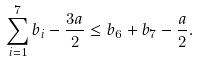Convert formula to latex. <formula><loc_0><loc_0><loc_500><loc_500>\sum _ { i = 1 } ^ { 7 } b _ { i } - \frac { 3 a } { 2 } \leq b _ { 6 } + b _ { 7 } - \frac { a } { 2 } .</formula> 